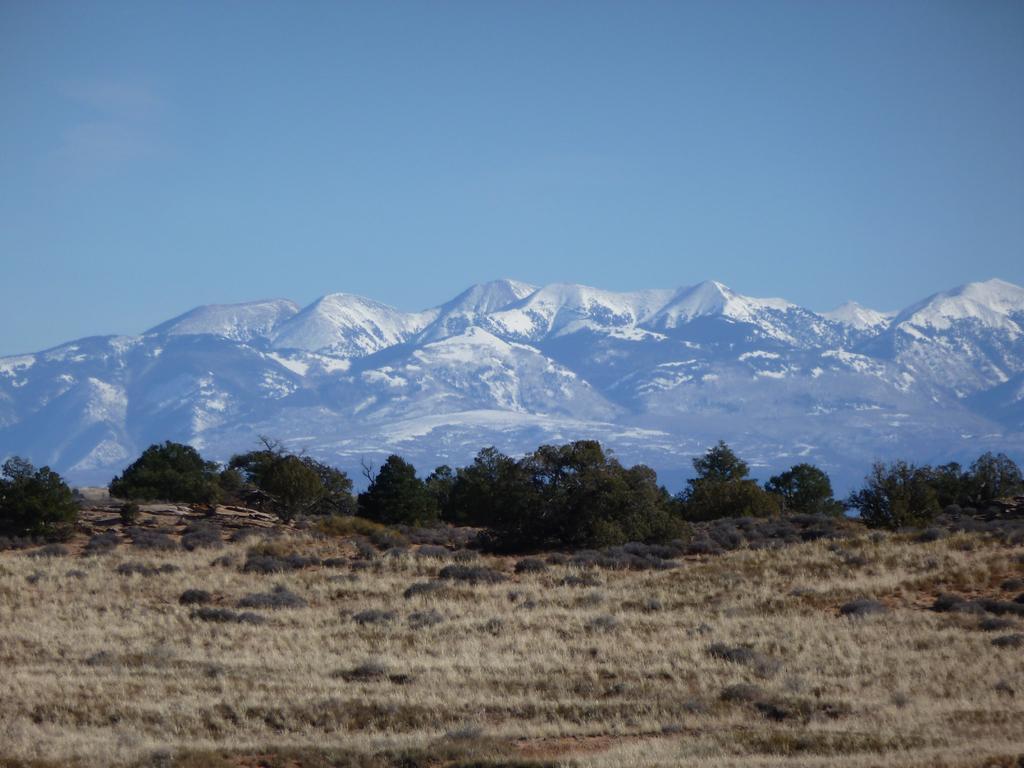Could you give a brief overview of what you see in this image? In this image there is the sky towards the top of the image, there are mountains, there are trees, there is ground towards the bottom of the image, there is grass, there are plants on the ground. 